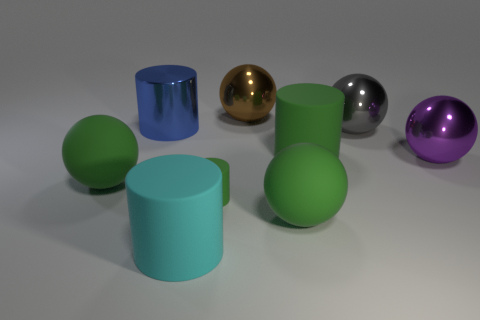How many large cylinders are on the right side of the large ball behind the gray sphere to the right of the tiny cylinder?
Offer a very short reply. 1. How many gray things are large rubber things or shiny cylinders?
Offer a very short reply. 0. Do the blue metal object and the green cylinder that is in front of the purple shiny sphere have the same size?
Your answer should be compact. No. There is a large blue thing that is the same shape as the big cyan object; what material is it?
Your answer should be very brief. Metal. What number of other things are the same size as the blue metal cylinder?
Ensure brevity in your answer.  7. What shape is the brown metal thing that is behind the big rubber cylinder to the right of the green rubber ball that is to the right of the cyan cylinder?
Provide a short and direct response. Sphere. What shape is the large rubber object that is on the left side of the large brown thing and behind the big cyan object?
Offer a very short reply. Sphere. How many things are either large metal things or metal spheres behind the large blue shiny thing?
Provide a succinct answer. 4. Is the material of the large cyan thing the same as the big purple thing?
Your answer should be very brief. No. How many other things are there of the same shape as the brown object?
Your answer should be very brief. 4. 